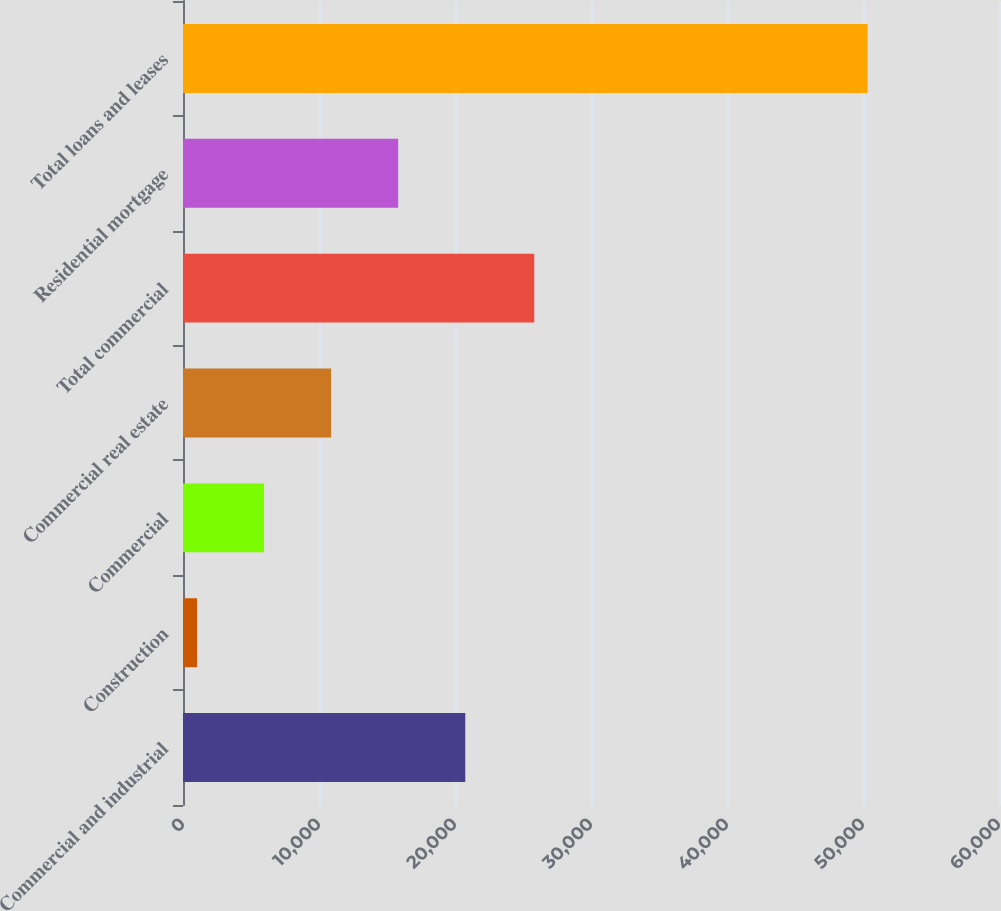<chart> <loc_0><loc_0><loc_500><loc_500><bar_chart><fcel>Commercial and industrial<fcel>Construction<fcel>Commercial<fcel>Commercial real estate<fcel>Total commercial<fcel>Residential mortgage<fcel>Total loans and leases<nl><fcel>20755<fcel>1031<fcel>5962<fcel>10893<fcel>25828<fcel>15824<fcel>50341<nl></chart> 